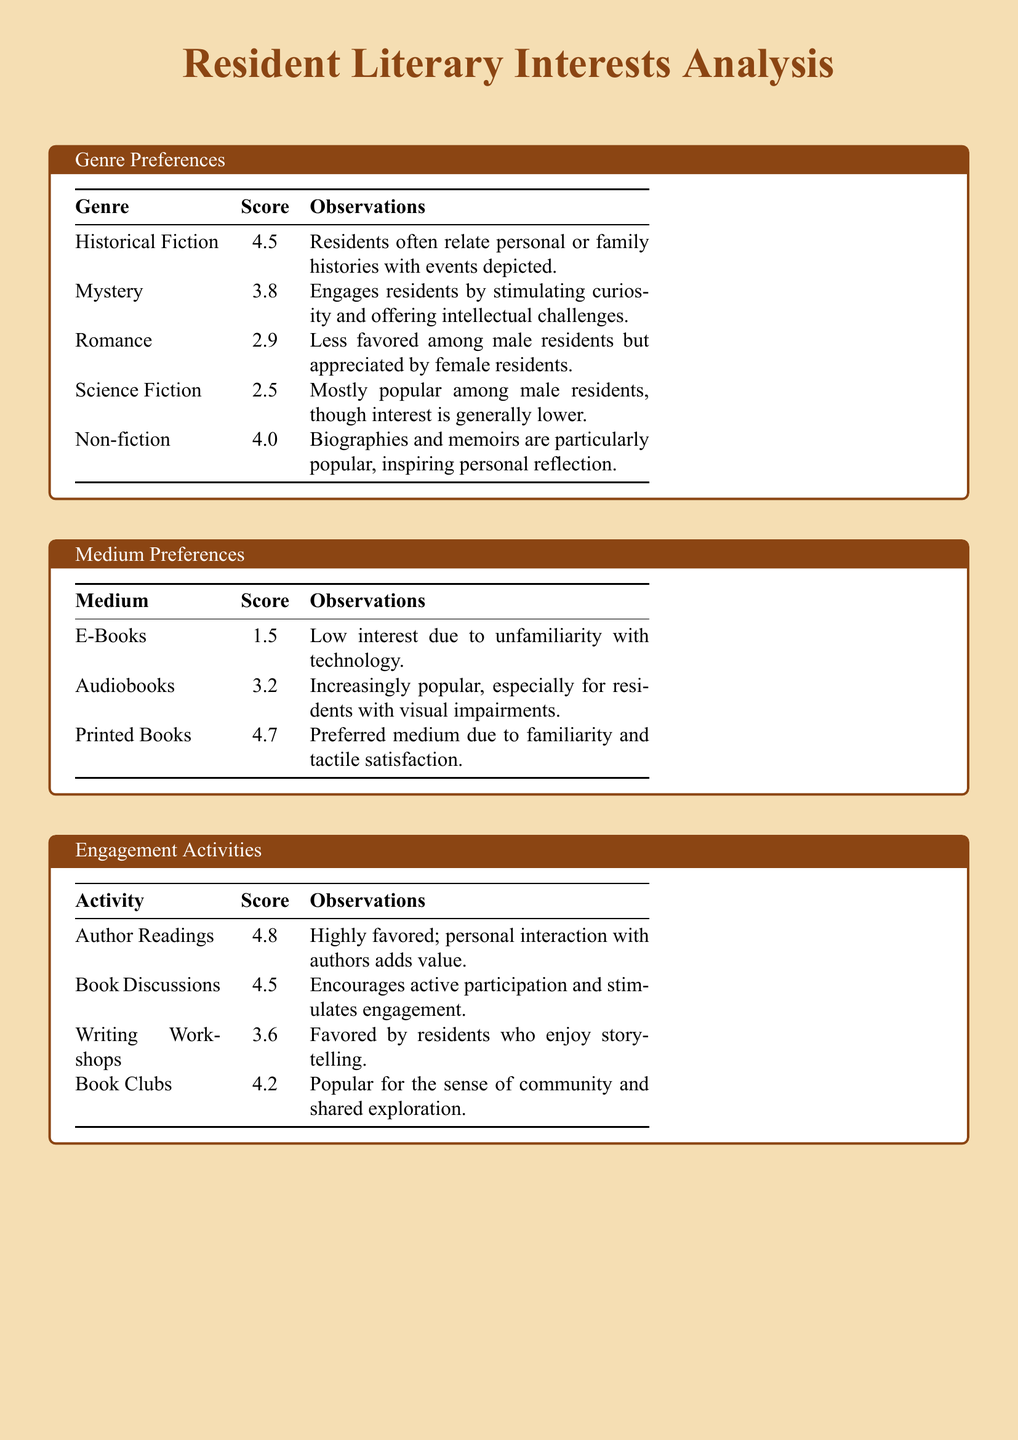What is the highest scored genre? The highest scored genre is Historical Fiction with a score of 4.5.
Answer: Historical Fiction Which medium has the lowest score? The medium with the lowest score is E-Books, scoring 1.5.
Answer: E-Books How popular is Audiobooks based on the score? Audiobooks received a score of 3.2, indicating moderate popularity.
Answer: 3.2 What type of activity received the highest score? The activity that received the highest score is Author Readings with a score of 4.8.
Answer: Author Readings Who is the author with a score of 4.2? The author with a score of 4.2 is Mitch Albom.
Answer: Mitch Albom How does the score for Non-fiction compare to Romance? Non-fiction has a score of 4.0, which is higher than Romance's score of 2.9.
Answer: Higher What is a common observation for Historical Fiction? Residents often relate personal or family histories with events depicted in Historical Fiction.
Answer: Relate personal histories What engagement activity fosters community feel among residents? The engagement activity that fosters a sense of community is Book Clubs, scoring 4.2.
Answer: Book Clubs Are printed books preferred over audiobooks? Yes, printed books have a higher score of 4.7 compared to audiobooks' score of 3.2.
Answer: Yes 